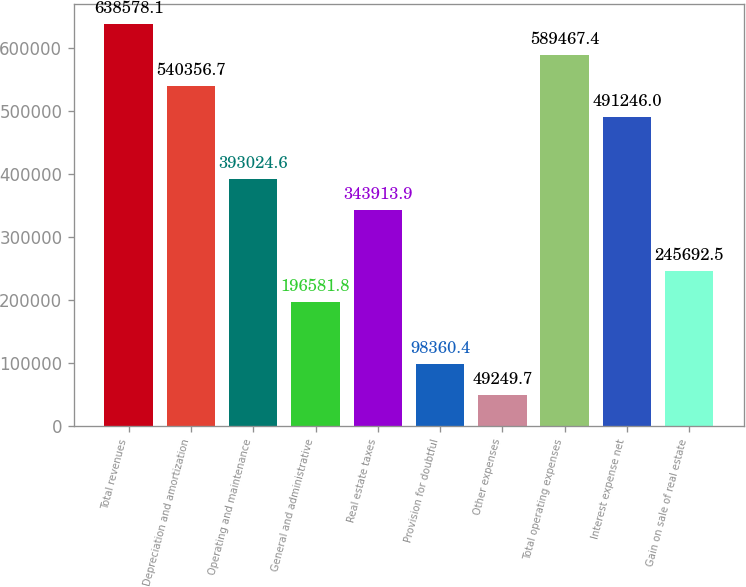Convert chart to OTSL. <chart><loc_0><loc_0><loc_500><loc_500><bar_chart><fcel>Total revenues<fcel>Depreciation and amortization<fcel>Operating and maintenance<fcel>General and administrative<fcel>Real estate taxes<fcel>Provision for doubtful<fcel>Other expenses<fcel>Total operating expenses<fcel>Interest expense net<fcel>Gain on sale of real estate<nl><fcel>638578<fcel>540357<fcel>393025<fcel>196582<fcel>343914<fcel>98360.4<fcel>49249.7<fcel>589467<fcel>491246<fcel>245692<nl></chart> 